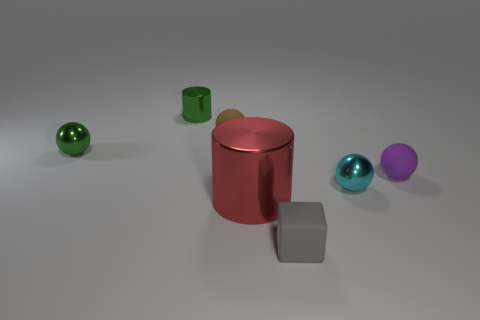Subtract 1 spheres. How many spheres are left? 3 Subtract all gray balls. Subtract all yellow cubes. How many balls are left? 4 Add 2 gray rubber cubes. How many objects exist? 9 Subtract all cylinders. How many objects are left? 5 Subtract all green balls. Subtract all small green shiny things. How many objects are left? 4 Add 6 small cyan spheres. How many small cyan spheres are left? 7 Add 6 green rubber cylinders. How many green rubber cylinders exist? 6 Subtract 1 green spheres. How many objects are left? 6 